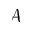Convert formula to latex. <formula><loc_0><loc_0><loc_500><loc_500>\mathcal { A }</formula> 